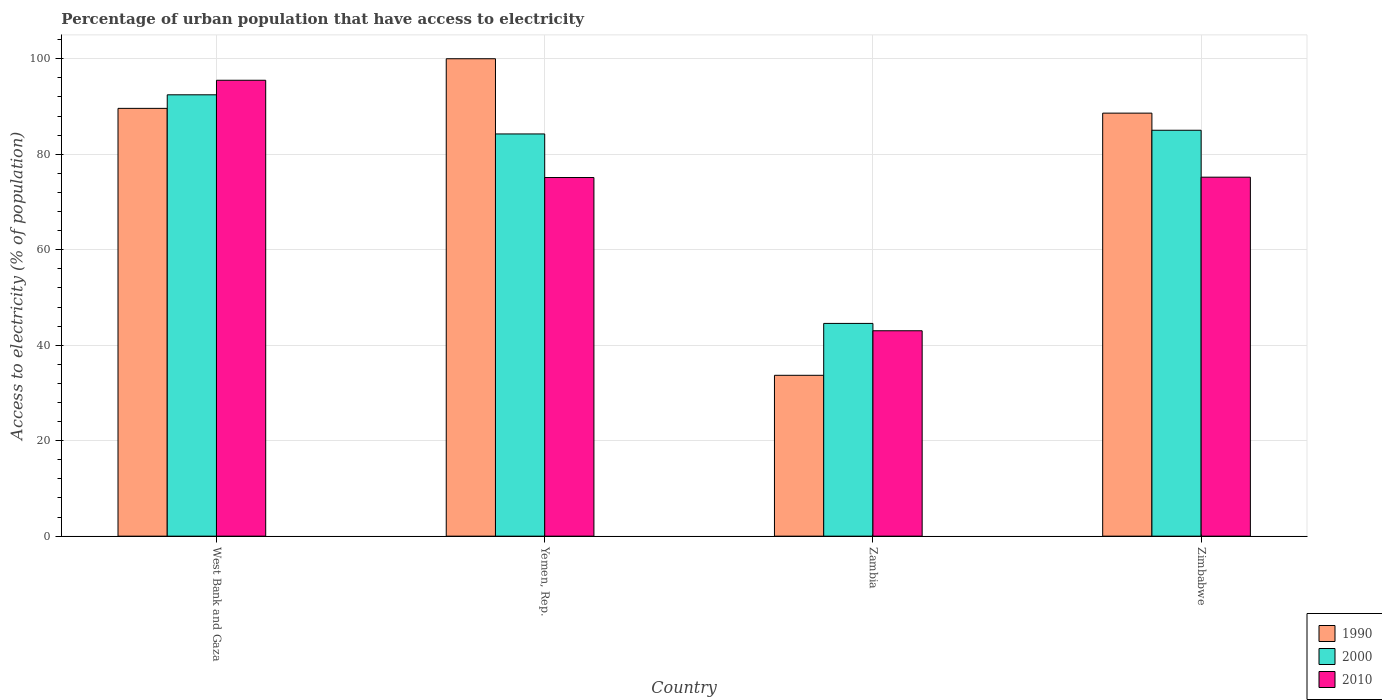How many different coloured bars are there?
Ensure brevity in your answer.  3. How many groups of bars are there?
Offer a terse response. 4. Are the number of bars on each tick of the X-axis equal?
Your answer should be very brief. Yes. What is the label of the 1st group of bars from the left?
Ensure brevity in your answer.  West Bank and Gaza. In how many cases, is the number of bars for a given country not equal to the number of legend labels?
Your answer should be very brief. 0. What is the percentage of urban population that have access to electricity in 2010 in Zimbabwe?
Offer a very short reply. 75.19. Across all countries, what is the minimum percentage of urban population that have access to electricity in 2010?
Provide a succinct answer. 43.03. In which country was the percentage of urban population that have access to electricity in 2010 maximum?
Provide a short and direct response. West Bank and Gaza. In which country was the percentage of urban population that have access to electricity in 2000 minimum?
Your answer should be very brief. Zambia. What is the total percentage of urban population that have access to electricity in 2000 in the graph?
Your answer should be very brief. 306.28. What is the difference between the percentage of urban population that have access to electricity in 1990 in West Bank and Gaza and that in Zambia?
Ensure brevity in your answer.  55.91. What is the difference between the percentage of urban population that have access to electricity in 2000 in Zimbabwe and the percentage of urban population that have access to electricity in 1990 in Yemen, Rep.?
Your answer should be very brief. -14.98. What is the average percentage of urban population that have access to electricity in 2000 per country?
Make the answer very short. 76.57. What is the difference between the percentage of urban population that have access to electricity of/in 1990 and percentage of urban population that have access to electricity of/in 2010 in West Bank and Gaza?
Give a very brief answer. -5.89. In how many countries, is the percentage of urban population that have access to electricity in 1990 greater than 76 %?
Provide a short and direct response. 3. What is the ratio of the percentage of urban population that have access to electricity in 2010 in Zambia to that in Zimbabwe?
Your response must be concise. 0.57. Is the difference between the percentage of urban population that have access to electricity in 1990 in West Bank and Gaza and Zimbabwe greater than the difference between the percentage of urban population that have access to electricity in 2010 in West Bank and Gaza and Zimbabwe?
Your answer should be very brief. No. What is the difference between the highest and the second highest percentage of urban population that have access to electricity in 1990?
Your answer should be very brief. -1. What is the difference between the highest and the lowest percentage of urban population that have access to electricity in 1990?
Offer a very short reply. 66.31. Is the sum of the percentage of urban population that have access to electricity in 2010 in Yemen, Rep. and Zambia greater than the maximum percentage of urban population that have access to electricity in 1990 across all countries?
Make the answer very short. Yes. What does the 2nd bar from the left in Yemen, Rep. represents?
Give a very brief answer. 2000. What does the 1st bar from the right in Zimbabwe represents?
Provide a succinct answer. 2010. Are all the bars in the graph horizontal?
Give a very brief answer. No. Are the values on the major ticks of Y-axis written in scientific E-notation?
Your answer should be very brief. No. Does the graph contain any zero values?
Ensure brevity in your answer.  No. Does the graph contain grids?
Keep it short and to the point. Yes. Where does the legend appear in the graph?
Your answer should be very brief. Bottom right. How are the legend labels stacked?
Offer a terse response. Vertical. What is the title of the graph?
Keep it short and to the point. Percentage of urban population that have access to electricity. Does "2009" appear as one of the legend labels in the graph?
Offer a terse response. No. What is the label or title of the Y-axis?
Ensure brevity in your answer.  Access to electricity (% of population). What is the Access to electricity (% of population) of 1990 in West Bank and Gaza?
Provide a succinct answer. 89.61. What is the Access to electricity (% of population) in 2000 in West Bank and Gaza?
Give a very brief answer. 92.45. What is the Access to electricity (% of population) of 2010 in West Bank and Gaza?
Offer a terse response. 95.5. What is the Access to electricity (% of population) in 1990 in Yemen, Rep.?
Offer a terse response. 100. What is the Access to electricity (% of population) of 2000 in Yemen, Rep.?
Your response must be concise. 84.25. What is the Access to electricity (% of population) in 2010 in Yemen, Rep.?
Make the answer very short. 75.12. What is the Access to electricity (% of population) of 1990 in Zambia?
Offer a terse response. 33.69. What is the Access to electricity (% of population) of 2000 in Zambia?
Your answer should be compact. 44.56. What is the Access to electricity (% of population) of 2010 in Zambia?
Your answer should be compact. 43.03. What is the Access to electricity (% of population) in 1990 in Zimbabwe?
Provide a short and direct response. 88.61. What is the Access to electricity (% of population) of 2000 in Zimbabwe?
Provide a short and direct response. 85.02. What is the Access to electricity (% of population) of 2010 in Zimbabwe?
Your response must be concise. 75.19. Across all countries, what is the maximum Access to electricity (% of population) in 1990?
Your answer should be very brief. 100. Across all countries, what is the maximum Access to electricity (% of population) in 2000?
Offer a very short reply. 92.45. Across all countries, what is the maximum Access to electricity (% of population) in 2010?
Your response must be concise. 95.5. Across all countries, what is the minimum Access to electricity (% of population) in 1990?
Provide a succinct answer. 33.69. Across all countries, what is the minimum Access to electricity (% of population) of 2000?
Offer a very short reply. 44.56. Across all countries, what is the minimum Access to electricity (% of population) of 2010?
Make the answer very short. 43.03. What is the total Access to electricity (% of population) in 1990 in the graph?
Your answer should be compact. 311.91. What is the total Access to electricity (% of population) in 2000 in the graph?
Keep it short and to the point. 306.28. What is the total Access to electricity (% of population) of 2010 in the graph?
Offer a terse response. 288.84. What is the difference between the Access to electricity (% of population) of 1990 in West Bank and Gaza and that in Yemen, Rep.?
Make the answer very short. -10.39. What is the difference between the Access to electricity (% of population) in 2000 in West Bank and Gaza and that in Yemen, Rep.?
Provide a succinct answer. 8.2. What is the difference between the Access to electricity (% of population) of 2010 in West Bank and Gaza and that in Yemen, Rep.?
Make the answer very short. 20.38. What is the difference between the Access to electricity (% of population) of 1990 in West Bank and Gaza and that in Zambia?
Give a very brief answer. 55.91. What is the difference between the Access to electricity (% of population) in 2000 in West Bank and Gaza and that in Zambia?
Offer a terse response. 47.88. What is the difference between the Access to electricity (% of population) in 2010 in West Bank and Gaza and that in Zambia?
Offer a very short reply. 52.47. What is the difference between the Access to electricity (% of population) in 1990 in West Bank and Gaza and that in Zimbabwe?
Provide a short and direct response. 1. What is the difference between the Access to electricity (% of population) in 2000 in West Bank and Gaza and that in Zimbabwe?
Offer a very short reply. 7.42. What is the difference between the Access to electricity (% of population) in 2010 in West Bank and Gaza and that in Zimbabwe?
Give a very brief answer. 20.3. What is the difference between the Access to electricity (% of population) of 1990 in Yemen, Rep. and that in Zambia?
Your answer should be compact. 66.31. What is the difference between the Access to electricity (% of population) in 2000 in Yemen, Rep. and that in Zambia?
Offer a very short reply. 39.68. What is the difference between the Access to electricity (% of population) of 2010 in Yemen, Rep. and that in Zambia?
Keep it short and to the point. 32.09. What is the difference between the Access to electricity (% of population) of 1990 in Yemen, Rep. and that in Zimbabwe?
Make the answer very short. 11.39. What is the difference between the Access to electricity (% of population) in 2000 in Yemen, Rep. and that in Zimbabwe?
Make the answer very short. -0.77. What is the difference between the Access to electricity (% of population) in 2010 in Yemen, Rep. and that in Zimbabwe?
Your answer should be compact. -0.07. What is the difference between the Access to electricity (% of population) of 1990 in Zambia and that in Zimbabwe?
Ensure brevity in your answer.  -54.92. What is the difference between the Access to electricity (% of population) in 2000 in Zambia and that in Zimbabwe?
Keep it short and to the point. -40.46. What is the difference between the Access to electricity (% of population) in 2010 in Zambia and that in Zimbabwe?
Give a very brief answer. -32.17. What is the difference between the Access to electricity (% of population) in 1990 in West Bank and Gaza and the Access to electricity (% of population) in 2000 in Yemen, Rep.?
Provide a short and direct response. 5.36. What is the difference between the Access to electricity (% of population) in 1990 in West Bank and Gaza and the Access to electricity (% of population) in 2010 in Yemen, Rep.?
Offer a very short reply. 14.49. What is the difference between the Access to electricity (% of population) in 2000 in West Bank and Gaza and the Access to electricity (% of population) in 2010 in Yemen, Rep.?
Give a very brief answer. 17.33. What is the difference between the Access to electricity (% of population) of 1990 in West Bank and Gaza and the Access to electricity (% of population) of 2000 in Zambia?
Provide a short and direct response. 45.04. What is the difference between the Access to electricity (% of population) in 1990 in West Bank and Gaza and the Access to electricity (% of population) in 2010 in Zambia?
Make the answer very short. 46.58. What is the difference between the Access to electricity (% of population) in 2000 in West Bank and Gaza and the Access to electricity (% of population) in 2010 in Zambia?
Your answer should be compact. 49.42. What is the difference between the Access to electricity (% of population) of 1990 in West Bank and Gaza and the Access to electricity (% of population) of 2000 in Zimbabwe?
Provide a short and direct response. 4.58. What is the difference between the Access to electricity (% of population) of 1990 in West Bank and Gaza and the Access to electricity (% of population) of 2010 in Zimbabwe?
Offer a very short reply. 14.41. What is the difference between the Access to electricity (% of population) in 2000 in West Bank and Gaza and the Access to electricity (% of population) in 2010 in Zimbabwe?
Give a very brief answer. 17.25. What is the difference between the Access to electricity (% of population) in 1990 in Yemen, Rep. and the Access to electricity (% of population) in 2000 in Zambia?
Offer a terse response. 55.44. What is the difference between the Access to electricity (% of population) of 1990 in Yemen, Rep. and the Access to electricity (% of population) of 2010 in Zambia?
Provide a succinct answer. 56.97. What is the difference between the Access to electricity (% of population) in 2000 in Yemen, Rep. and the Access to electricity (% of population) in 2010 in Zambia?
Offer a very short reply. 41.22. What is the difference between the Access to electricity (% of population) of 1990 in Yemen, Rep. and the Access to electricity (% of population) of 2000 in Zimbabwe?
Keep it short and to the point. 14.98. What is the difference between the Access to electricity (% of population) of 1990 in Yemen, Rep. and the Access to electricity (% of population) of 2010 in Zimbabwe?
Your response must be concise. 24.81. What is the difference between the Access to electricity (% of population) in 2000 in Yemen, Rep. and the Access to electricity (% of population) in 2010 in Zimbabwe?
Give a very brief answer. 9.05. What is the difference between the Access to electricity (% of population) of 1990 in Zambia and the Access to electricity (% of population) of 2000 in Zimbabwe?
Provide a succinct answer. -51.33. What is the difference between the Access to electricity (% of population) of 1990 in Zambia and the Access to electricity (% of population) of 2010 in Zimbabwe?
Offer a terse response. -41.5. What is the difference between the Access to electricity (% of population) of 2000 in Zambia and the Access to electricity (% of population) of 2010 in Zimbabwe?
Give a very brief answer. -30.63. What is the average Access to electricity (% of population) of 1990 per country?
Your answer should be compact. 77.98. What is the average Access to electricity (% of population) of 2000 per country?
Ensure brevity in your answer.  76.57. What is the average Access to electricity (% of population) of 2010 per country?
Ensure brevity in your answer.  72.21. What is the difference between the Access to electricity (% of population) of 1990 and Access to electricity (% of population) of 2000 in West Bank and Gaza?
Keep it short and to the point. -2.84. What is the difference between the Access to electricity (% of population) of 1990 and Access to electricity (% of population) of 2010 in West Bank and Gaza?
Give a very brief answer. -5.89. What is the difference between the Access to electricity (% of population) of 2000 and Access to electricity (% of population) of 2010 in West Bank and Gaza?
Give a very brief answer. -3.05. What is the difference between the Access to electricity (% of population) in 1990 and Access to electricity (% of population) in 2000 in Yemen, Rep.?
Ensure brevity in your answer.  15.75. What is the difference between the Access to electricity (% of population) in 1990 and Access to electricity (% of population) in 2010 in Yemen, Rep.?
Keep it short and to the point. 24.88. What is the difference between the Access to electricity (% of population) in 2000 and Access to electricity (% of population) in 2010 in Yemen, Rep.?
Your answer should be compact. 9.13. What is the difference between the Access to electricity (% of population) of 1990 and Access to electricity (% of population) of 2000 in Zambia?
Keep it short and to the point. -10.87. What is the difference between the Access to electricity (% of population) of 1990 and Access to electricity (% of population) of 2010 in Zambia?
Keep it short and to the point. -9.33. What is the difference between the Access to electricity (% of population) of 2000 and Access to electricity (% of population) of 2010 in Zambia?
Provide a short and direct response. 1.54. What is the difference between the Access to electricity (% of population) in 1990 and Access to electricity (% of population) in 2000 in Zimbabwe?
Your answer should be compact. 3.59. What is the difference between the Access to electricity (% of population) in 1990 and Access to electricity (% of population) in 2010 in Zimbabwe?
Offer a terse response. 13.41. What is the difference between the Access to electricity (% of population) of 2000 and Access to electricity (% of population) of 2010 in Zimbabwe?
Offer a very short reply. 9.83. What is the ratio of the Access to electricity (% of population) in 1990 in West Bank and Gaza to that in Yemen, Rep.?
Ensure brevity in your answer.  0.9. What is the ratio of the Access to electricity (% of population) of 2000 in West Bank and Gaza to that in Yemen, Rep.?
Ensure brevity in your answer.  1.1. What is the ratio of the Access to electricity (% of population) of 2010 in West Bank and Gaza to that in Yemen, Rep.?
Offer a very short reply. 1.27. What is the ratio of the Access to electricity (% of population) in 1990 in West Bank and Gaza to that in Zambia?
Provide a succinct answer. 2.66. What is the ratio of the Access to electricity (% of population) of 2000 in West Bank and Gaza to that in Zambia?
Make the answer very short. 2.07. What is the ratio of the Access to electricity (% of population) in 2010 in West Bank and Gaza to that in Zambia?
Your response must be concise. 2.22. What is the ratio of the Access to electricity (% of population) in 1990 in West Bank and Gaza to that in Zimbabwe?
Your answer should be compact. 1.01. What is the ratio of the Access to electricity (% of population) in 2000 in West Bank and Gaza to that in Zimbabwe?
Your answer should be very brief. 1.09. What is the ratio of the Access to electricity (% of population) of 2010 in West Bank and Gaza to that in Zimbabwe?
Offer a very short reply. 1.27. What is the ratio of the Access to electricity (% of population) of 1990 in Yemen, Rep. to that in Zambia?
Make the answer very short. 2.97. What is the ratio of the Access to electricity (% of population) of 2000 in Yemen, Rep. to that in Zambia?
Offer a terse response. 1.89. What is the ratio of the Access to electricity (% of population) in 2010 in Yemen, Rep. to that in Zambia?
Make the answer very short. 1.75. What is the ratio of the Access to electricity (% of population) in 1990 in Yemen, Rep. to that in Zimbabwe?
Ensure brevity in your answer.  1.13. What is the ratio of the Access to electricity (% of population) in 2000 in Yemen, Rep. to that in Zimbabwe?
Give a very brief answer. 0.99. What is the ratio of the Access to electricity (% of population) of 2010 in Yemen, Rep. to that in Zimbabwe?
Ensure brevity in your answer.  1. What is the ratio of the Access to electricity (% of population) in 1990 in Zambia to that in Zimbabwe?
Give a very brief answer. 0.38. What is the ratio of the Access to electricity (% of population) of 2000 in Zambia to that in Zimbabwe?
Your answer should be compact. 0.52. What is the ratio of the Access to electricity (% of population) of 2010 in Zambia to that in Zimbabwe?
Provide a succinct answer. 0.57. What is the difference between the highest and the second highest Access to electricity (% of population) in 1990?
Offer a very short reply. 10.39. What is the difference between the highest and the second highest Access to electricity (% of population) in 2000?
Keep it short and to the point. 7.42. What is the difference between the highest and the second highest Access to electricity (% of population) in 2010?
Your answer should be very brief. 20.3. What is the difference between the highest and the lowest Access to electricity (% of population) in 1990?
Give a very brief answer. 66.31. What is the difference between the highest and the lowest Access to electricity (% of population) in 2000?
Offer a terse response. 47.88. What is the difference between the highest and the lowest Access to electricity (% of population) in 2010?
Your answer should be very brief. 52.47. 